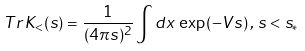Convert formula to latex. <formula><loc_0><loc_0><loc_500><loc_500>T r \, K _ { < } ( s ) = \frac { 1 } { ( 4 \pi s ) ^ { 2 } } \int d x \, \exp \left ( - V s \right ) , \, s < s _ { \ast }</formula> 